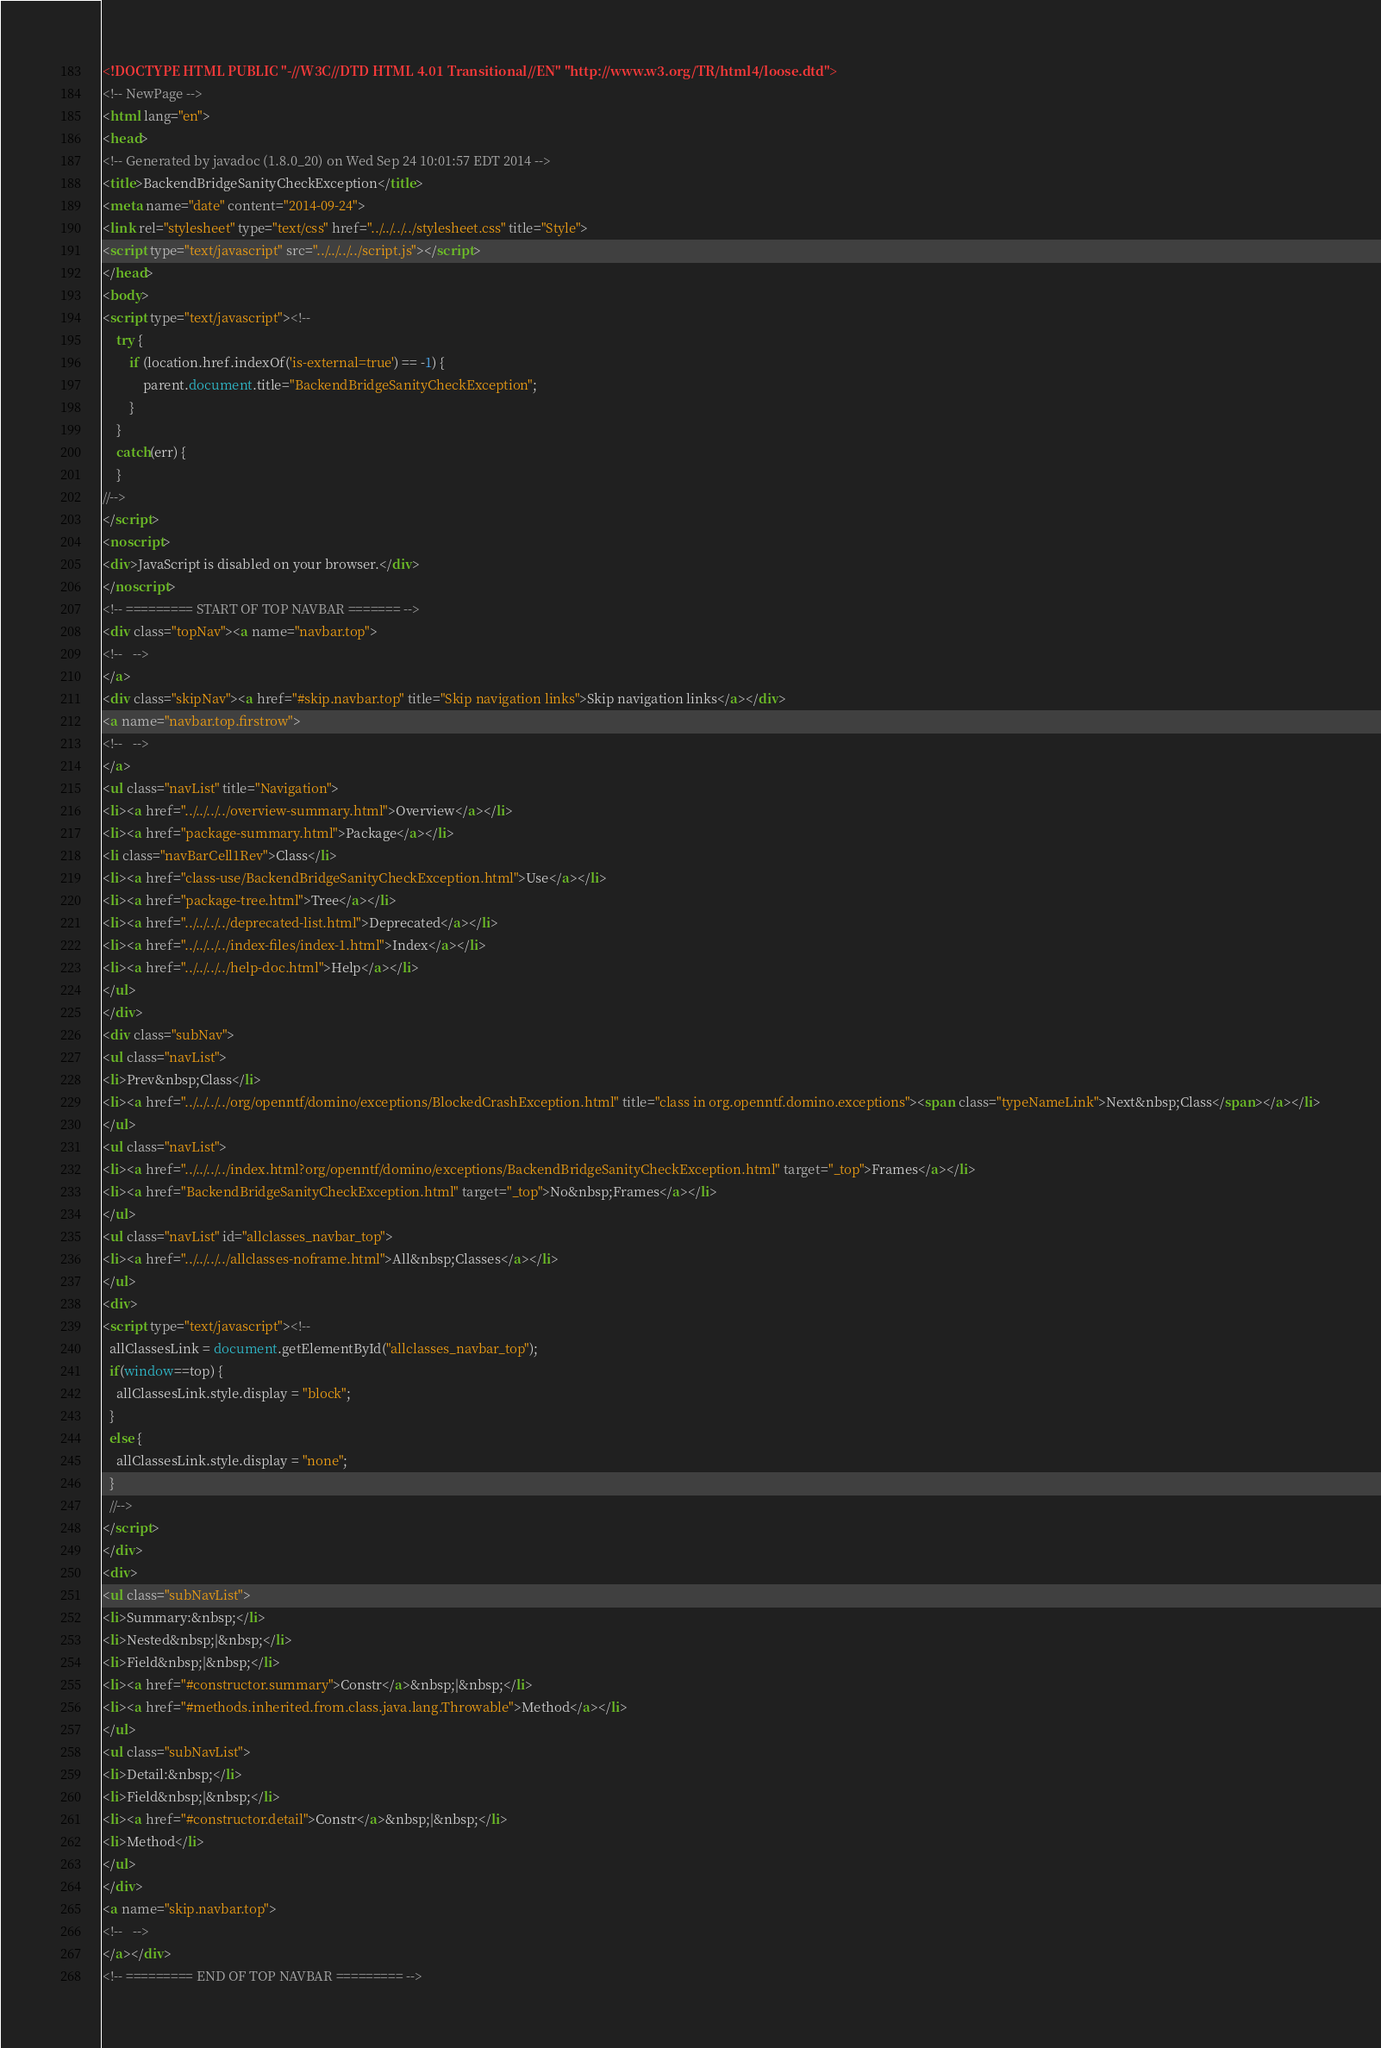Convert code to text. <code><loc_0><loc_0><loc_500><loc_500><_HTML_><!DOCTYPE HTML PUBLIC "-//W3C//DTD HTML 4.01 Transitional//EN" "http://www.w3.org/TR/html4/loose.dtd">
<!-- NewPage -->
<html lang="en">
<head>
<!-- Generated by javadoc (1.8.0_20) on Wed Sep 24 10:01:57 EDT 2014 -->
<title>BackendBridgeSanityCheckException</title>
<meta name="date" content="2014-09-24">
<link rel="stylesheet" type="text/css" href="../../../../stylesheet.css" title="Style">
<script type="text/javascript" src="../../../../script.js"></script>
</head>
<body>
<script type="text/javascript"><!--
    try {
        if (location.href.indexOf('is-external=true') == -1) {
            parent.document.title="BackendBridgeSanityCheckException";
        }
    }
    catch(err) {
    }
//-->
</script>
<noscript>
<div>JavaScript is disabled on your browser.</div>
</noscript>
<!-- ========= START OF TOP NAVBAR ======= -->
<div class="topNav"><a name="navbar.top">
<!--   -->
</a>
<div class="skipNav"><a href="#skip.navbar.top" title="Skip navigation links">Skip navigation links</a></div>
<a name="navbar.top.firstrow">
<!--   -->
</a>
<ul class="navList" title="Navigation">
<li><a href="../../../../overview-summary.html">Overview</a></li>
<li><a href="package-summary.html">Package</a></li>
<li class="navBarCell1Rev">Class</li>
<li><a href="class-use/BackendBridgeSanityCheckException.html">Use</a></li>
<li><a href="package-tree.html">Tree</a></li>
<li><a href="../../../../deprecated-list.html">Deprecated</a></li>
<li><a href="../../../../index-files/index-1.html">Index</a></li>
<li><a href="../../../../help-doc.html">Help</a></li>
</ul>
</div>
<div class="subNav">
<ul class="navList">
<li>Prev&nbsp;Class</li>
<li><a href="../../../../org/openntf/domino/exceptions/BlockedCrashException.html" title="class in org.openntf.domino.exceptions"><span class="typeNameLink">Next&nbsp;Class</span></a></li>
</ul>
<ul class="navList">
<li><a href="../../../../index.html?org/openntf/domino/exceptions/BackendBridgeSanityCheckException.html" target="_top">Frames</a></li>
<li><a href="BackendBridgeSanityCheckException.html" target="_top">No&nbsp;Frames</a></li>
</ul>
<ul class="navList" id="allclasses_navbar_top">
<li><a href="../../../../allclasses-noframe.html">All&nbsp;Classes</a></li>
</ul>
<div>
<script type="text/javascript"><!--
  allClassesLink = document.getElementById("allclasses_navbar_top");
  if(window==top) {
    allClassesLink.style.display = "block";
  }
  else {
    allClassesLink.style.display = "none";
  }
  //-->
</script>
</div>
<div>
<ul class="subNavList">
<li>Summary:&nbsp;</li>
<li>Nested&nbsp;|&nbsp;</li>
<li>Field&nbsp;|&nbsp;</li>
<li><a href="#constructor.summary">Constr</a>&nbsp;|&nbsp;</li>
<li><a href="#methods.inherited.from.class.java.lang.Throwable">Method</a></li>
</ul>
<ul class="subNavList">
<li>Detail:&nbsp;</li>
<li>Field&nbsp;|&nbsp;</li>
<li><a href="#constructor.detail">Constr</a>&nbsp;|&nbsp;</li>
<li>Method</li>
</ul>
</div>
<a name="skip.navbar.top">
<!--   -->
</a></div>
<!-- ========= END OF TOP NAVBAR ========= --></code> 